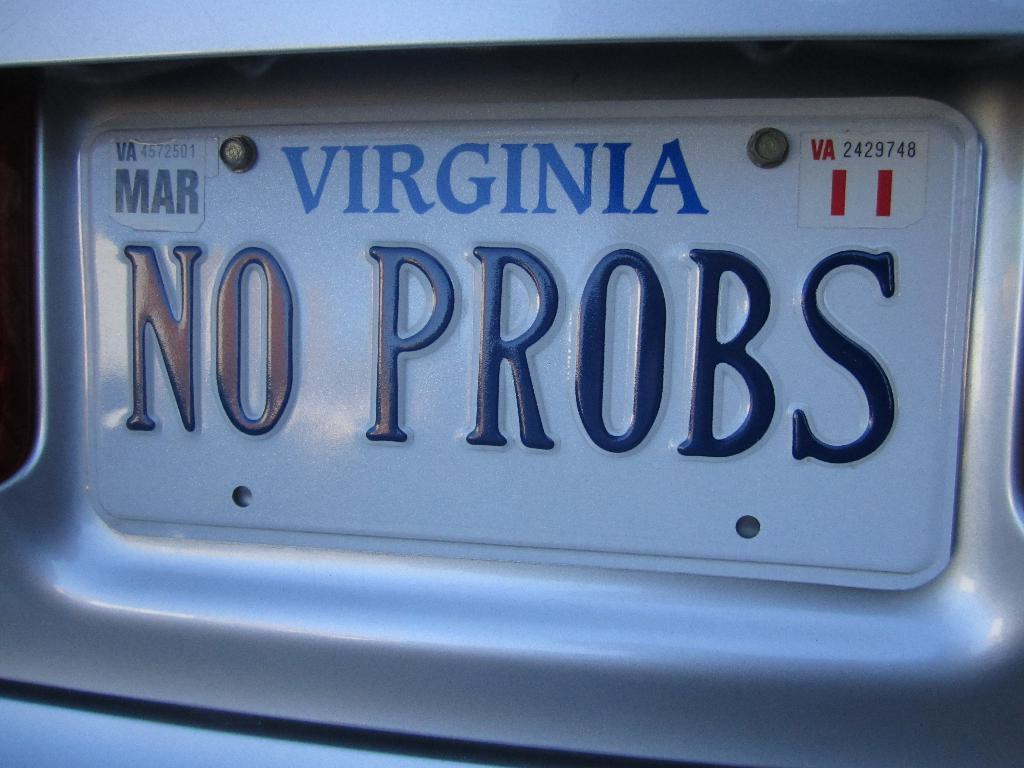<image>
Give a short and clear explanation of the subsequent image. A license plate on the back of a vehicle says NO PROBS. 